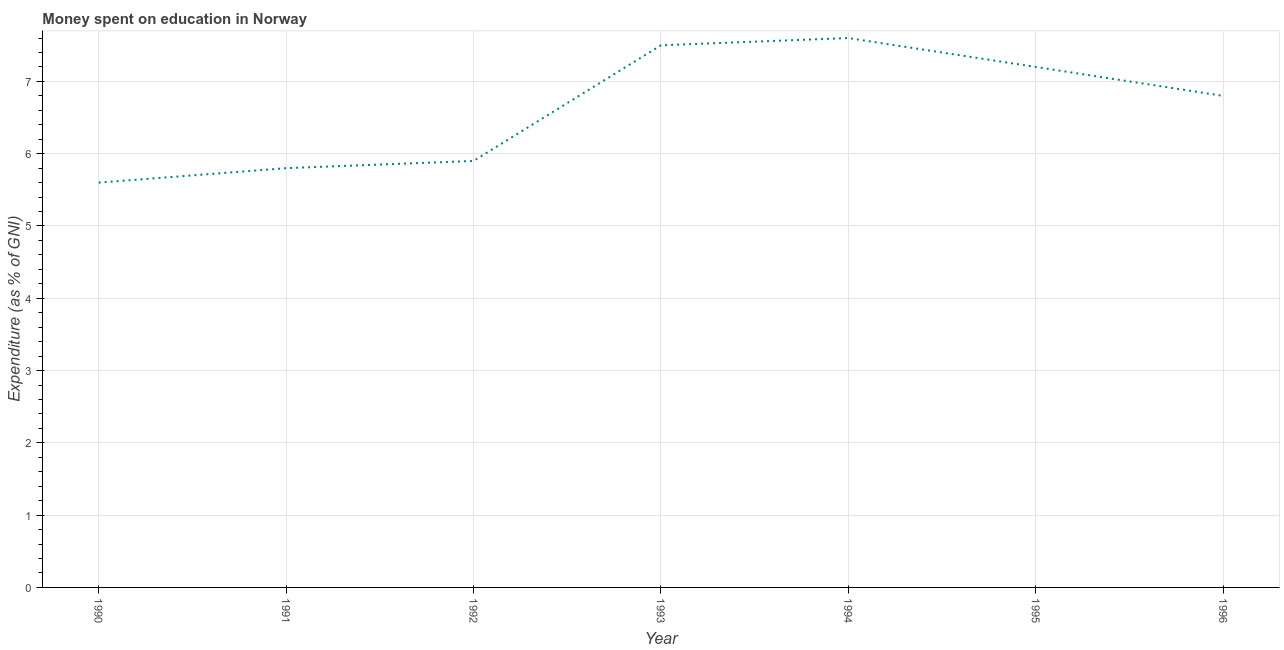Across all years, what is the minimum expenditure on education?
Ensure brevity in your answer.  5.6. In which year was the expenditure on education minimum?
Ensure brevity in your answer.  1990. What is the sum of the expenditure on education?
Your response must be concise. 46.4. What is the difference between the expenditure on education in 1990 and 1993?
Keep it short and to the point. -1.9. What is the average expenditure on education per year?
Make the answer very short. 6.63. What is the median expenditure on education?
Provide a short and direct response. 6.8. In how many years, is the expenditure on education greater than 6.8 %?
Make the answer very short. 3. What is the ratio of the expenditure on education in 1995 to that in 1996?
Provide a succinct answer. 1.06. Is the difference between the expenditure on education in 1992 and 1994 greater than the difference between any two years?
Offer a terse response. No. What is the difference between the highest and the second highest expenditure on education?
Ensure brevity in your answer.  0.1. Is the sum of the expenditure on education in 1991 and 1994 greater than the maximum expenditure on education across all years?
Offer a very short reply. Yes. Does the expenditure on education monotonically increase over the years?
Keep it short and to the point. No. How many lines are there?
Give a very brief answer. 1. How many years are there in the graph?
Your answer should be very brief. 7. Does the graph contain grids?
Offer a terse response. Yes. What is the title of the graph?
Offer a very short reply. Money spent on education in Norway. What is the label or title of the X-axis?
Ensure brevity in your answer.  Year. What is the label or title of the Y-axis?
Offer a terse response. Expenditure (as % of GNI). What is the Expenditure (as % of GNI) of 1990?
Give a very brief answer. 5.6. What is the Expenditure (as % of GNI) of 1993?
Make the answer very short. 7.5. What is the Expenditure (as % of GNI) of 1994?
Make the answer very short. 7.6. What is the difference between the Expenditure (as % of GNI) in 1990 and 1992?
Give a very brief answer. -0.3. What is the difference between the Expenditure (as % of GNI) in 1990 and 1993?
Provide a succinct answer. -1.9. What is the difference between the Expenditure (as % of GNI) in 1990 and 1994?
Keep it short and to the point. -2. What is the difference between the Expenditure (as % of GNI) in 1990 and 1995?
Keep it short and to the point. -1.6. What is the difference between the Expenditure (as % of GNI) in 1990 and 1996?
Make the answer very short. -1.2. What is the difference between the Expenditure (as % of GNI) in 1991 and 1992?
Offer a very short reply. -0.1. What is the difference between the Expenditure (as % of GNI) in 1991 and 1995?
Offer a very short reply. -1.4. What is the difference between the Expenditure (as % of GNI) in 1992 and 1996?
Your answer should be compact. -0.9. What is the difference between the Expenditure (as % of GNI) in 1993 and 1995?
Keep it short and to the point. 0.3. What is the difference between the Expenditure (as % of GNI) in 1994 and 1995?
Ensure brevity in your answer.  0.4. What is the difference between the Expenditure (as % of GNI) in 1994 and 1996?
Your response must be concise. 0.8. What is the difference between the Expenditure (as % of GNI) in 1995 and 1996?
Your response must be concise. 0.4. What is the ratio of the Expenditure (as % of GNI) in 1990 to that in 1992?
Provide a short and direct response. 0.95. What is the ratio of the Expenditure (as % of GNI) in 1990 to that in 1993?
Give a very brief answer. 0.75. What is the ratio of the Expenditure (as % of GNI) in 1990 to that in 1994?
Ensure brevity in your answer.  0.74. What is the ratio of the Expenditure (as % of GNI) in 1990 to that in 1995?
Give a very brief answer. 0.78. What is the ratio of the Expenditure (as % of GNI) in 1990 to that in 1996?
Ensure brevity in your answer.  0.82. What is the ratio of the Expenditure (as % of GNI) in 1991 to that in 1992?
Offer a very short reply. 0.98. What is the ratio of the Expenditure (as % of GNI) in 1991 to that in 1993?
Offer a very short reply. 0.77. What is the ratio of the Expenditure (as % of GNI) in 1991 to that in 1994?
Provide a short and direct response. 0.76. What is the ratio of the Expenditure (as % of GNI) in 1991 to that in 1995?
Provide a short and direct response. 0.81. What is the ratio of the Expenditure (as % of GNI) in 1991 to that in 1996?
Offer a terse response. 0.85. What is the ratio of the Expenditure (as % of GNI) in 1992 to that in 1993?
Your response must be concise. 0.79. What is the ratio of the Expenditure (as % of GNI) in 1992 to that in 1994?
Make the answer very short. 0.78. What is the ratio of the Expenditure (as % of GNI) in 1992 to that in 1995?
Ensure brevity in your answer.  0.82. What is the ratio of the Expenditure (as % of GNI) in 1992 to that in 1996?
Keep it short and to the point. 0.87. What is the ratio of the Expenditure (as % of GNI) in 1993 to that in 1995?
Offer a very short reply. 1.04. What is the ratio of the Expenditure (as % of GNI) in 1993 to that in 1996?
Provide a short and direct response. 1.1. What is the ratio of the Expenditure (as % of GNI) in 1994 to that in 1995?
Your response must be concise. 1.06. What is the ratio of the Expenditure (as % of GNI) in 1994 to that in 1996?
Give a very brief answer. 1.12. What is the ratio of the Expenditure (as % of GNI) in 1995 to that in 1996?
Provide a succinct answer. 1.06. 